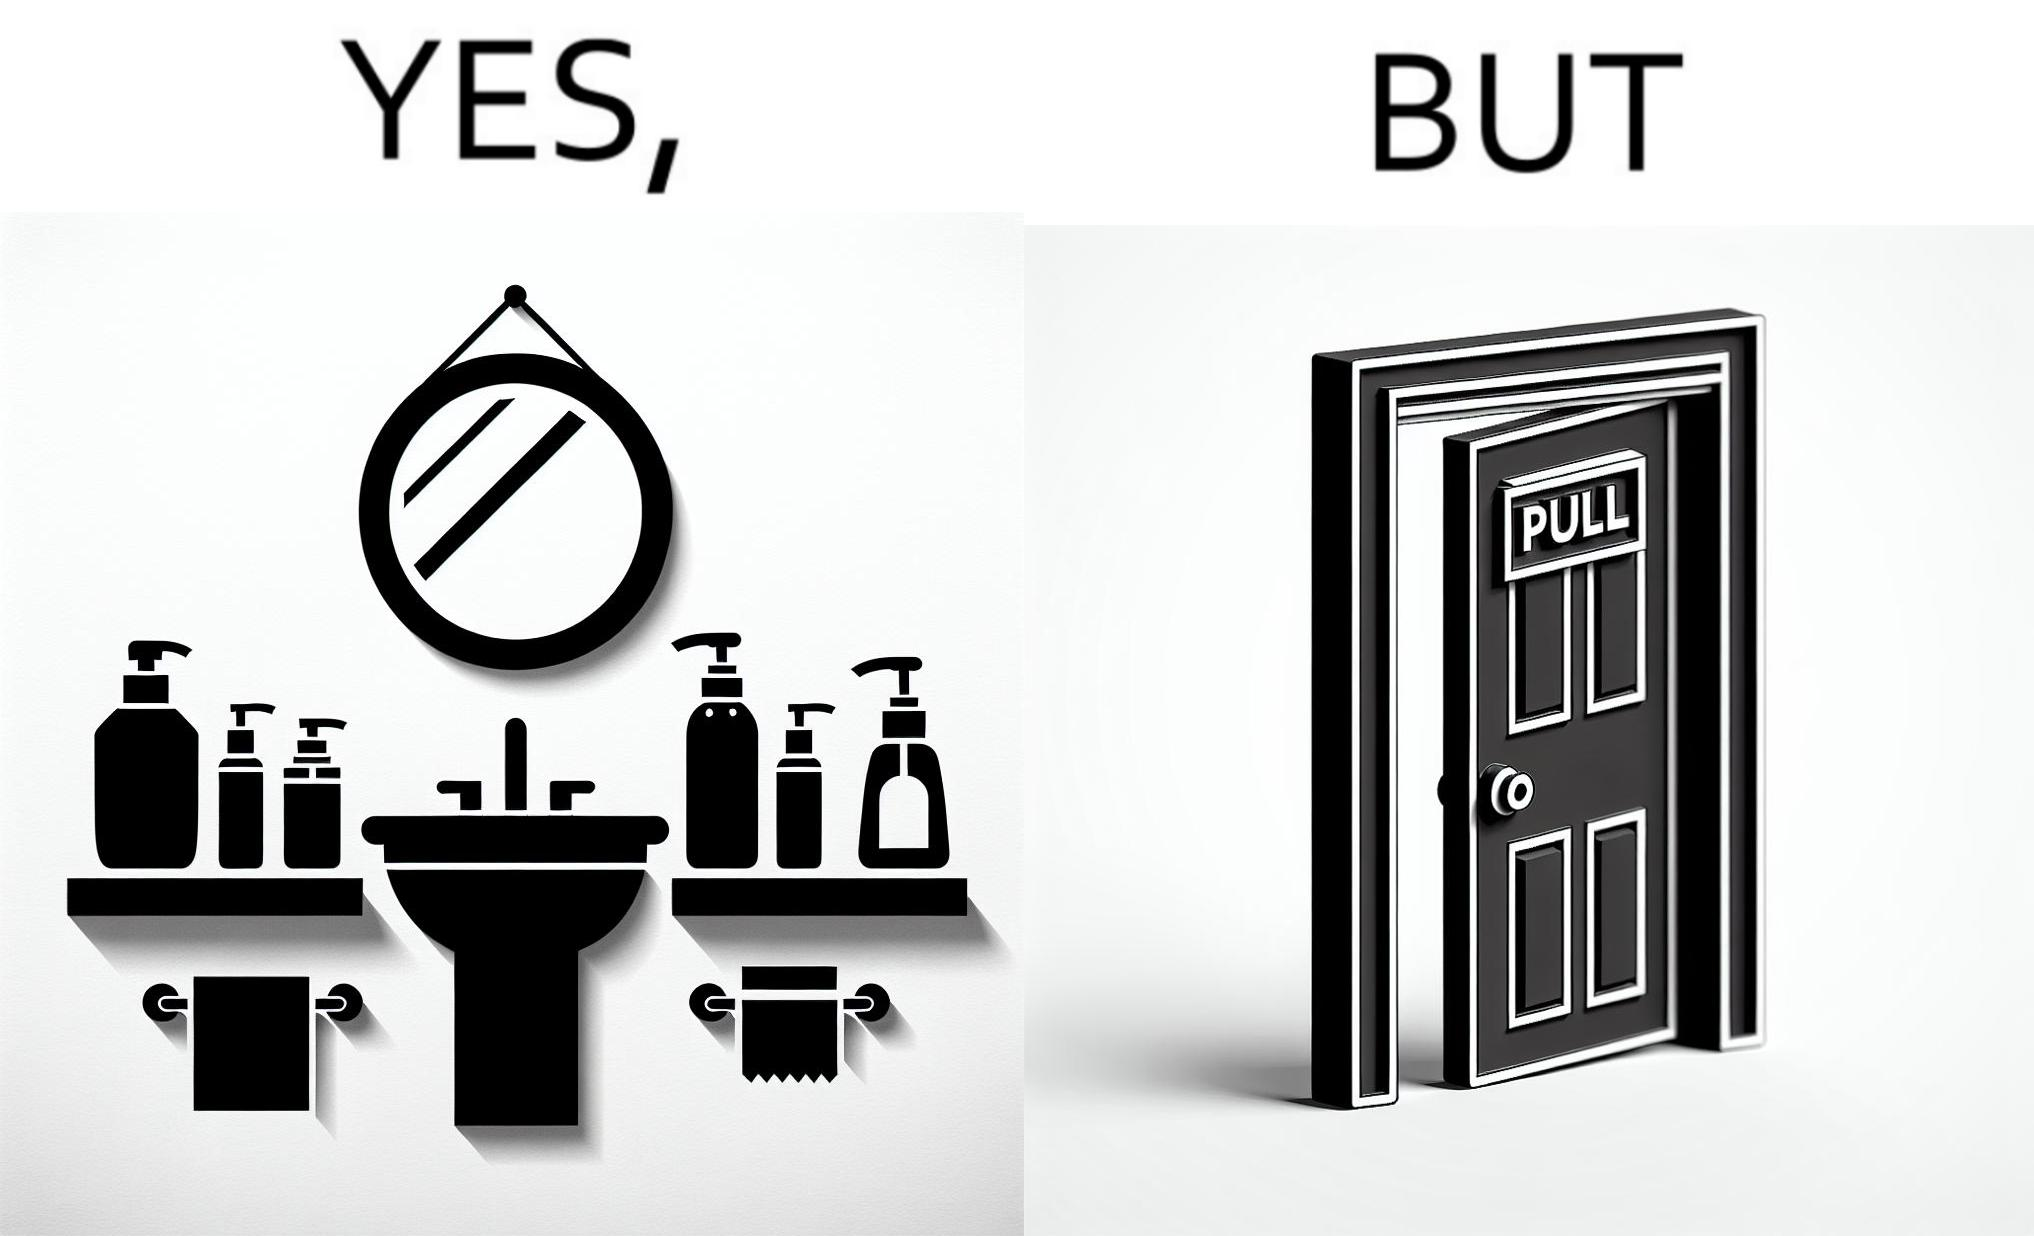Explain the humor or irony in this image. The image is ironic, because in the first image in the bathroom there are so many things to clean hands around the basin but in the same bathroom people have to open the doors by hand which can easily spread the germs or bacteria even after times of hand cleaning as there is no way to open it without hands 